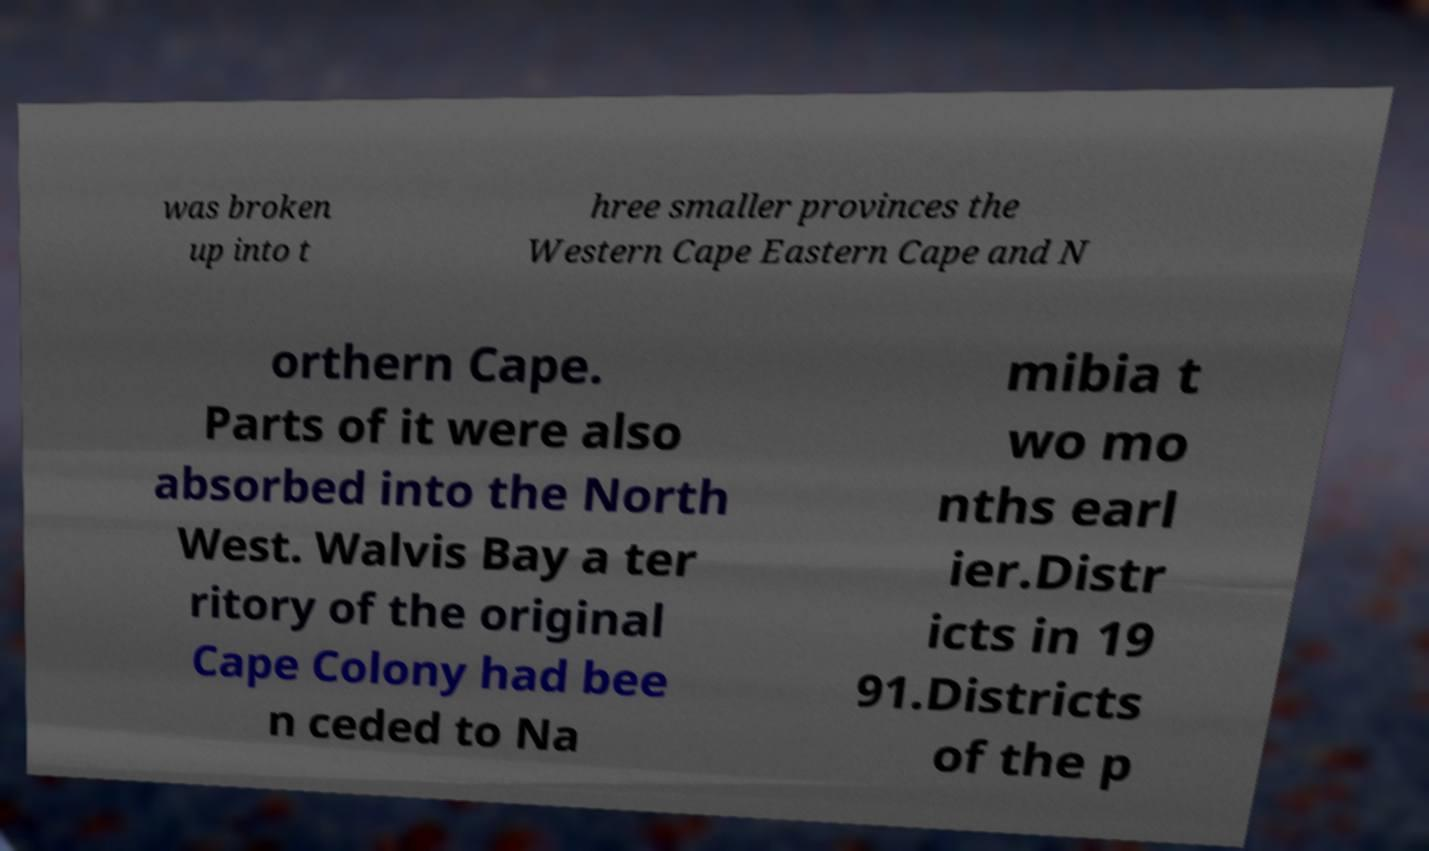Could you assist in decoding the text presented in this image and type it out clearly? was broken up into t hree smaller provinces the Western Cape Eastern Cape and N orthern Cape. Parts of it were also absorbed into the North West. Walvis Bay a ter ritory of the original Cape Colony had bee n ceded to Na mibia t wo mo nths earl ier.Distr icts in 19 91.Districts of the p 